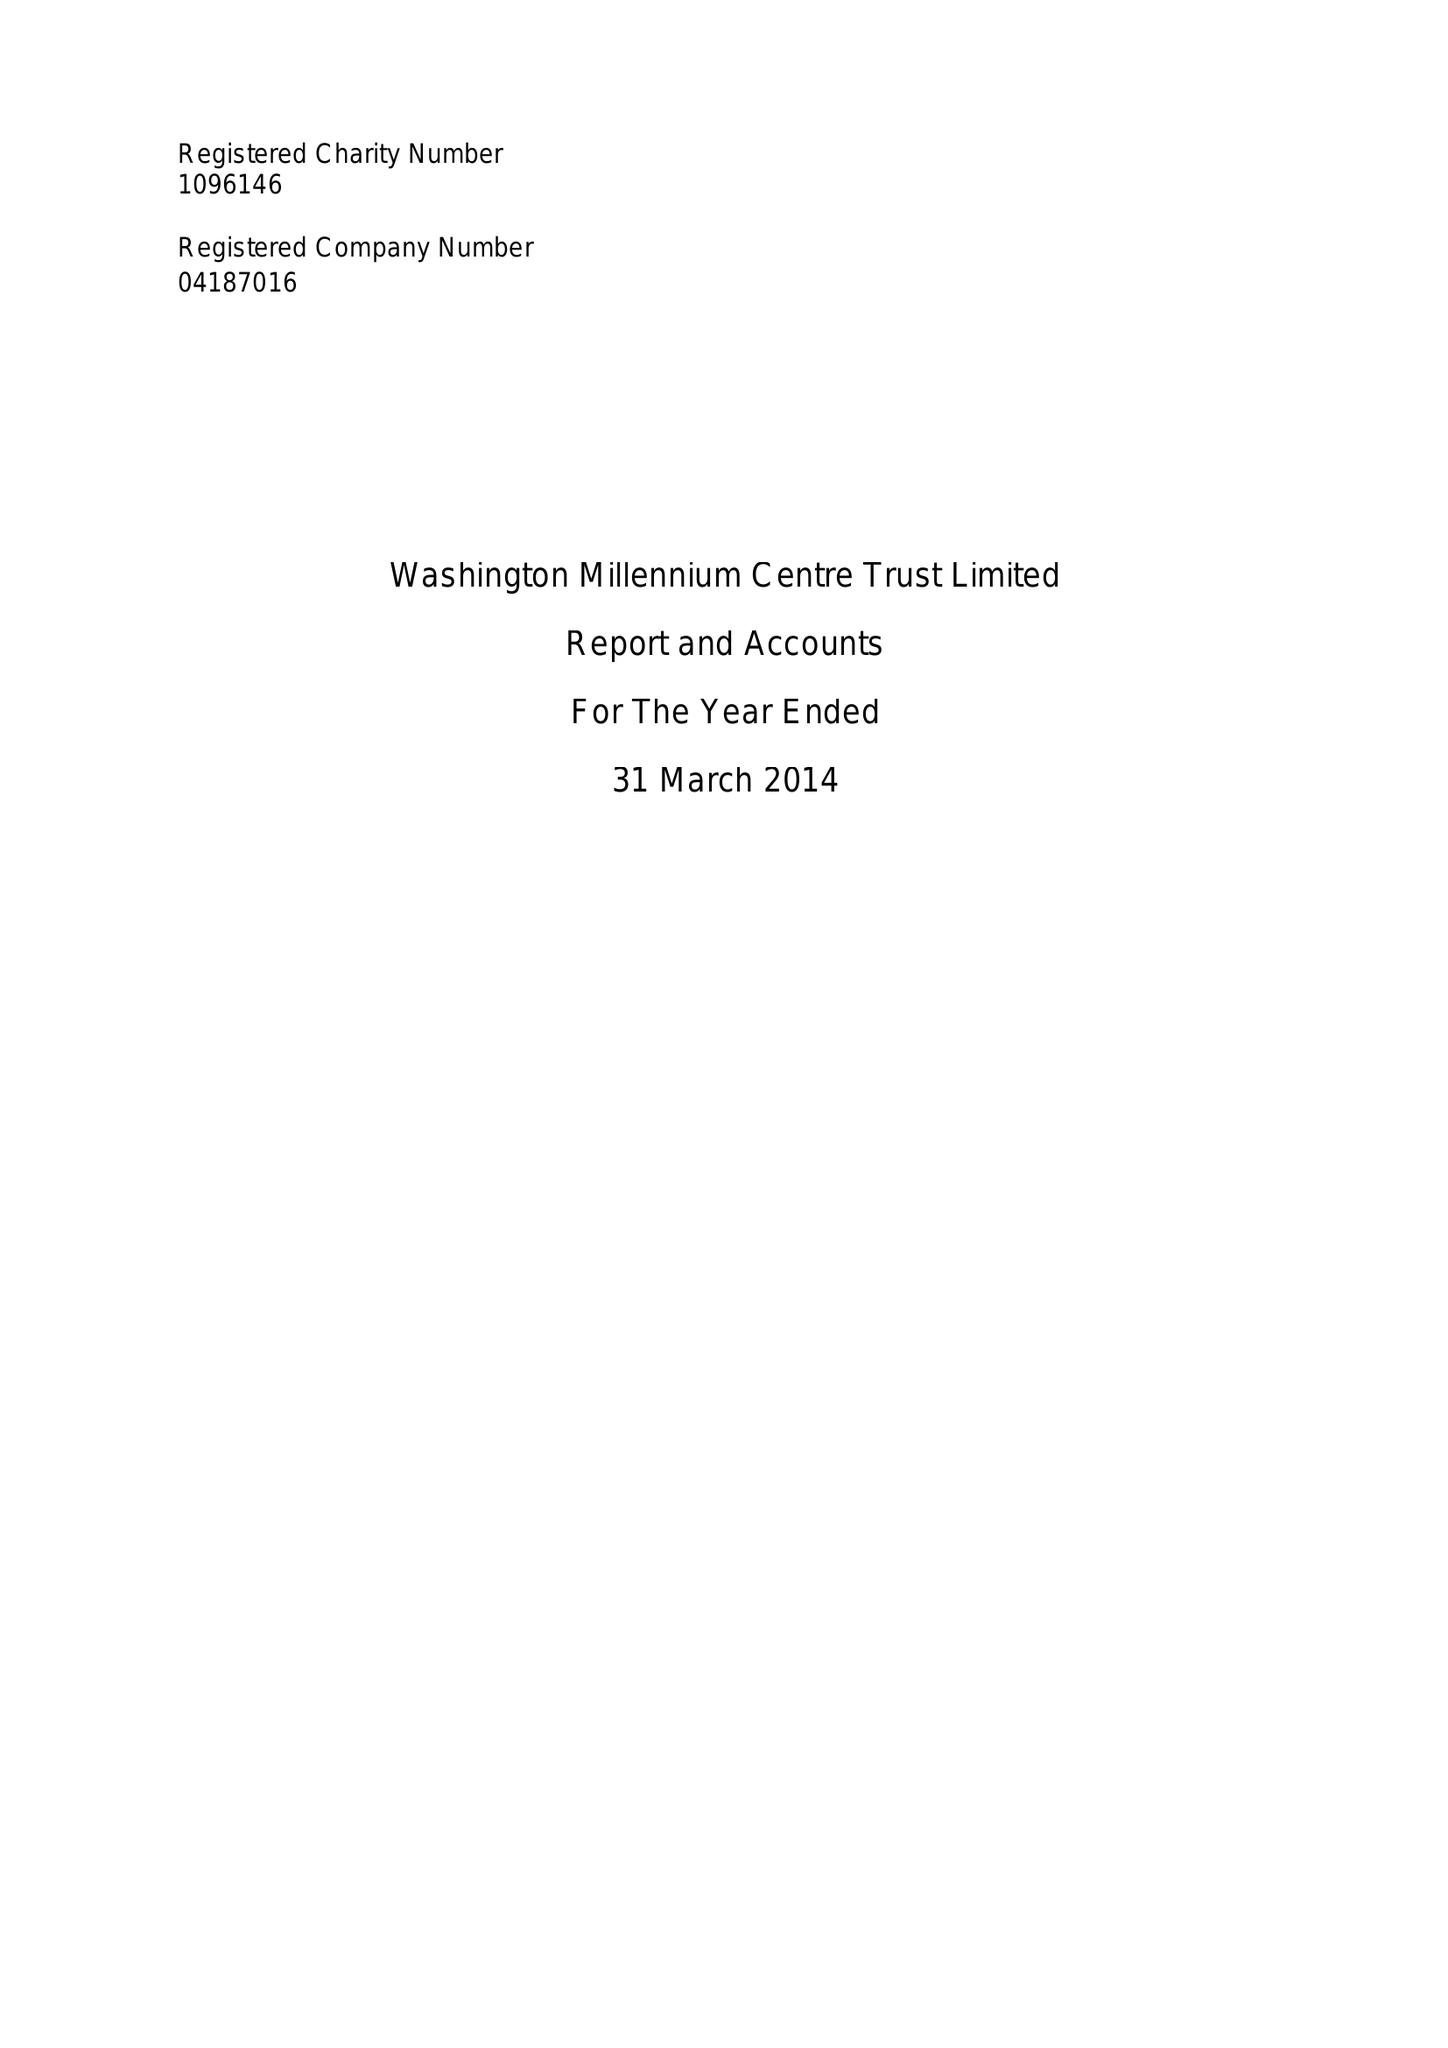What is the value for the report_date?
Answer the question using a single word or phrase. 2014-03-31 